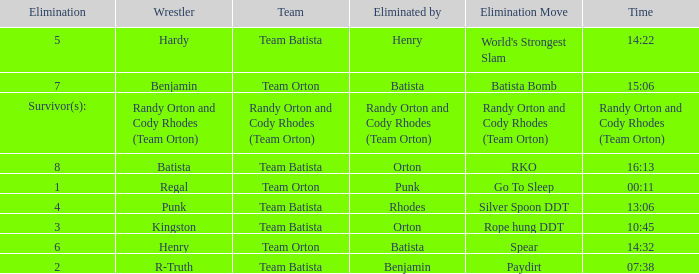Which Elimination Move is listed at Elimination 8 for Team Batista? RKO. 